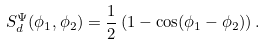Convert formula to latex. <formula><loc_0><loc_0><loc_500><loc_500>S ^ { \Psi } _ { d } ( \phi _ { 1 } , \phi _ { 2 } ) = \frac { 1 } { 2 } \left ( 1 - \cos ( \phi _ { 1 } - \phi _ { 2 } ) \right ) .</formula> 